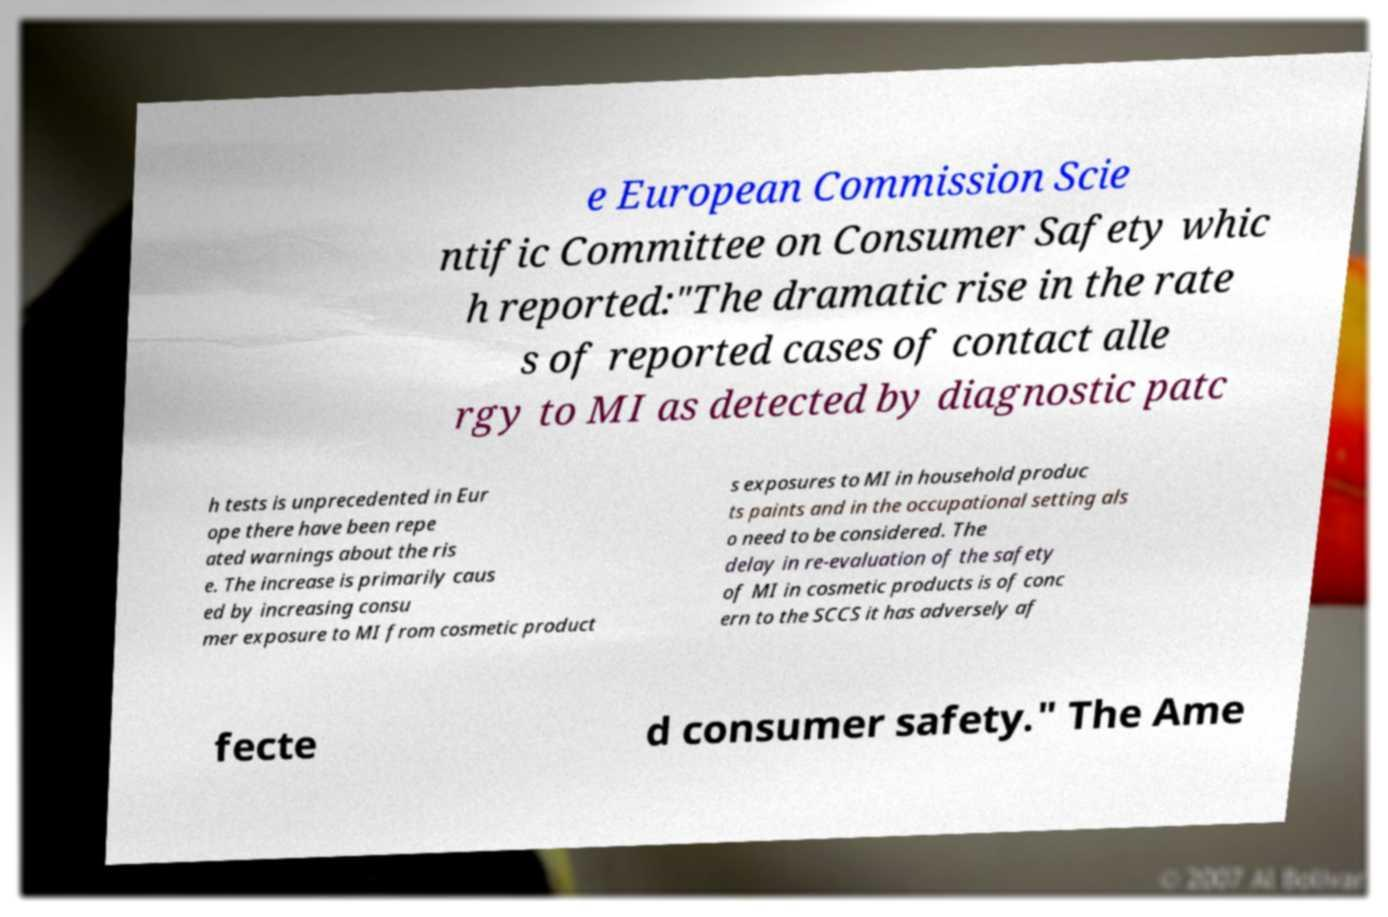Can you accurately transcribe the text from the provided image for me? e European Commission Scie ntific Committee on Consumer Safety whic h reported:"The dramatic rise in the rate s of reported cases of contact alle rgy to MI as detected by diagnostic patc h tests is unprecedented in Eur ope there have been repe ated warnings about the ris e. The increase is primarily caus ed by increasing consu mer exposure to MI from cosmetic product s exposures to MI in household produc ts paints and in the occupational setting als o need to be considered. The delay in re-evaluation of the safety of MI in cosmetic products is of conc ern to the SCCS it has adversely af fecte d consumer safety." The Ame 